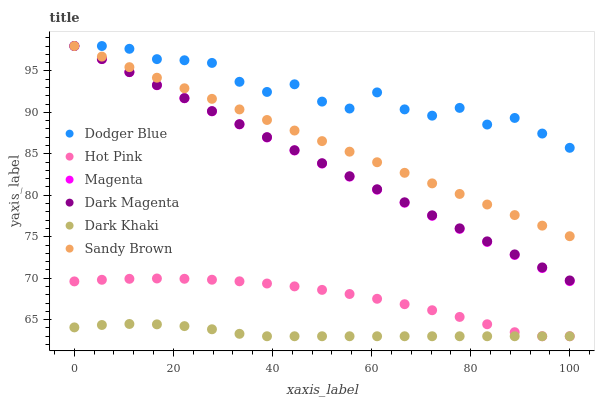Does Dark Khaki have the minimum area under the curve?
Answer yes or no. Yes. Does Dodger Blue have the maximum area under the curve?
Answer yes or no. Yes. Does Hot Pink have the minimum area under the curve?
Answer yes or no. No. Does Hot Pink have the maximum area under the curve?
Answer yes or no. No. Is Dark Magenta the smoothest?
Answer yes or no. Yes. Is Dodger Blue the roughest?
Answer yes or no. Yes. Is Hot Pink the smoothest?
Answer yes or no. No. Is Hot Pink the roughest?
Answer yes or no. No. Does Hot Pink have the lowest value?
Answer yes or no. Yes. Does Dodger Blue have the lowest value?
Answer yes or no. No. Does Sandy Brown have the highest value?
Answer yes or no. Yes. Does Hot Pink have the highest value?
Answer yes or no. No. Is Dark Khaki less than Sandy Brown?
Answer yes or no. Yes. Is Dark Magenta greater than Hot Pink?
Answer yes or no. Yes. Does Sandy Brown intersect Dodger Blue?
Answer yes or no. Yes. Is Sandy Brown less than Dodger Blue?
Answer yes or no. No. Is Sandy Brown greater than Dodger Blue?
Answer yes or no. No. Does Dark Khaki intersect Sandy Brown?
Answer yes or no. No. 